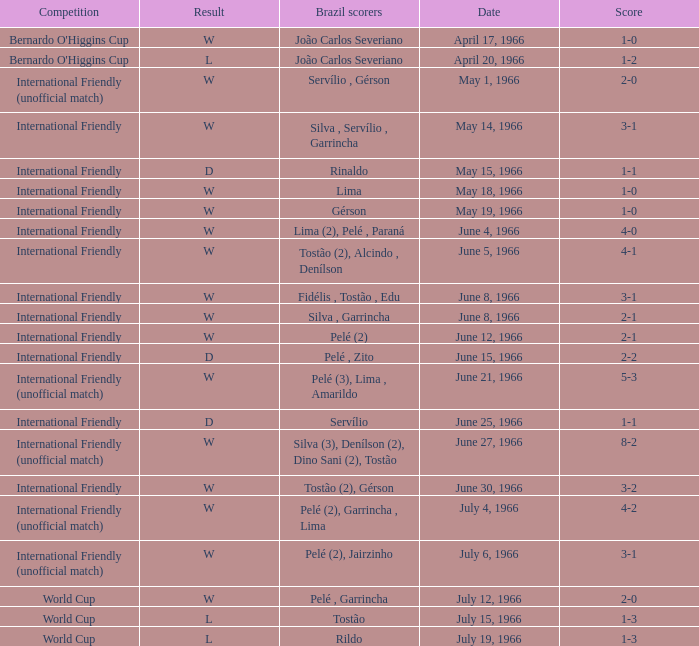Could you parse the entire table? {'header': ['Competition', 'Result', 'Brazil scorers', 'Date', 'Score'], 'rows': [["Bernardo O'Higgins Cup", 'W', 'João Carlos Severiano', 'April 17, 1966', '1-0'], ["Bernardo O'Higgins Cup", 'L', 'João Carlos Severiano', 'April 20, 1966', '1-2'], ['International Friendly (unofficial match)', 'W', 'Servílio , Gérson', 'May 1, 1966', '2-0'], ['International Friendly', 'W', 'Silva , Servílio , Garrincha', 'May 14, 1966', '3-1'], ['International Friendly', 'D', 'Rinaldo', 'May 15, 1966', '1-1'], ['International Friendly', 'W', 'Lima', 'May 18, 1966', '1-0'], ['International Friendly', 'W', 'Gérson', 'May 19, 1966', '1-0'], ['International Friendly', 'W', 'Lima (2), Pelé , Paraná', 'June 4, 1966', '4-0'], ['International Friendly', 'W', 'Tostão (2), Alcindo , Denílson', 'June 5, 1966', '4-1'], ['International Friendly', 'W', 'Fidélis , Tostão , Edu', 'June 8, 1966', '3-1'], ['International Friendly', 'W', 'Silva , Garrincha', 'June 8, 1966', '2-1'], ['International Friendly', 'W', 'Pelé (2)', 'June 12, 1966', '2-1'], ['International Friendly', 'D', 'Pelé , Zito', 'June 15, 1966', '2-2'], ['International Friendly (unofficial match)', 'W', 'Pelé (3), Lima , Amarildo', 'June 21, 1966', '5-3'], ['International Friendly', 'D', 'Servílio', 'June 25, 1966', '1-1'], ['International Friendly (unofficial match)', 'W', 'Silva (3), Denílson (2), Dino Sani (2), Tostão', 'June 27, 1966', '8-2'], ['International Friendly', 'W', 'Tostão (2), Gérson', 'June 30, 1966', '3-2'], ['International Friendly (unofficial match)', 'W', 'Pelé (2), Garrincha , Lima', 'July 4, 1966', '4-2'], ['International Friendly (unofficial match)', 'W', 'Pelé (2), Jairzinho', 'July 6, 1966', '3-1'], ['World Cup', 'W', 'Pelé , Garrincha', 'July 12, 1966', '2-0'], ['World Cup', 'L', 'Tostão', 'July 15, 1966', '1-3'], ['World Cup', 'L', 'Rildo', 'July 19, 1966', '1-3']]} What is the result of the International Friendly competition on May 15, 1966? D. 